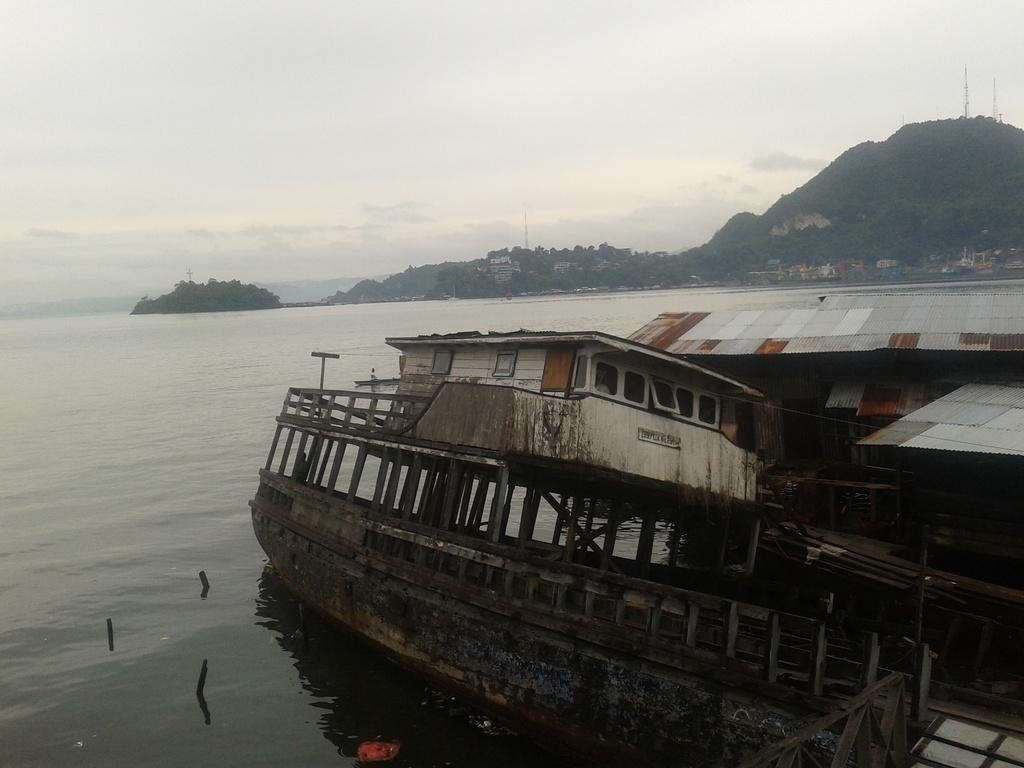What type of structure is located on the right side of the image? There is a metal shed on the right side of the image. What natural feature is at the center of the image? There is a river at the center of the image. What can be seen in the background of the image? There is a mountain and the sky visible in the background of the image. What type of nerve treatment is being performed on the mountain in the image? There is no nerve treatment being performed in the image; it features a metal shed, a river, a mountain, and the sky. Can you describe the dental work being done on the river in the image? There is no dental work being done in the image; it features a metal shed, a river, a mountain, and the sky. 